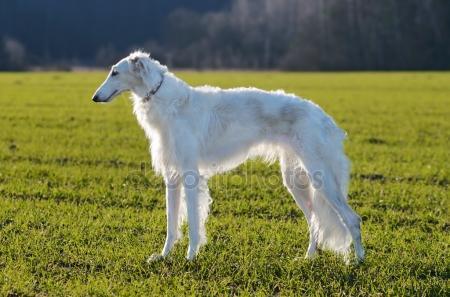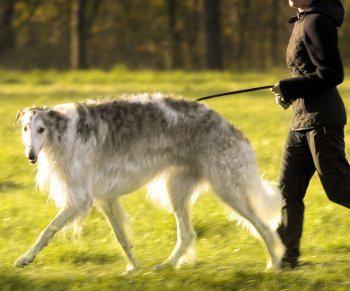The first image is the image on the left, the second image is the image on the right. Assess this claim about the two images: "A person is upright near a hound in one image.". Correct or not? Answer yes or no. Yes. The first image is the image on the left, the second image is the image on the right. For the images shown, is this caption "there is exactly one person in the image on the right." true? Answer yes or no. Yes. 